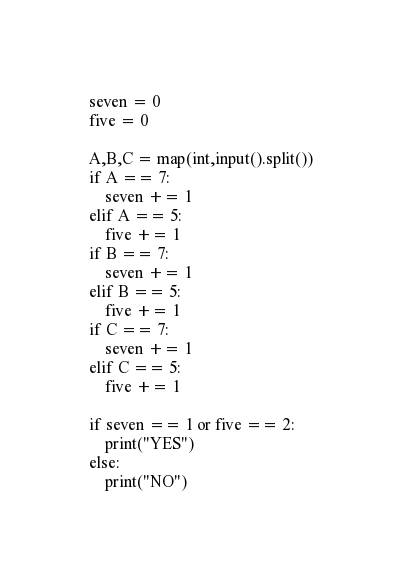<code> <loc_0><loc_0><loc_500><loc_500><_Python_>seven = 0
five = 0

A,B,C = map(int,input().split())
if A == 7:
    seven += 1
elif A == 5:
    five += 1
if B == 7:
    seven += 1
elif B == 5:
    five += 1
if C == 7:
    seven += 1
elif C == 5:
    five += 1
    
if seven == 1 or five == 2:
    print("YES")
else:
    print("NO")</code> 